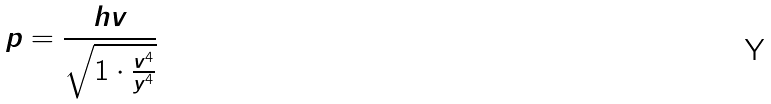<formula> <loc_0><loc_0><loc_500><loc_500>p = \frac { h v } { \sqrt { 1 \cdot \frac { v ^ { 4 } } { y ^ { 4 } } } }</formula> 